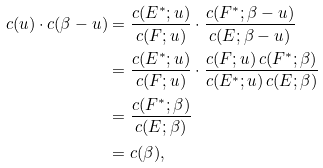Convert formula to latex. <formula><loc_0><loc_0><loc_500><loc_500>c ( u ) \cdot c ( \beta - u ) & = \frac { c ( E ^ { * } ; u ) } { c ( F ; u ) } \cdot \frac { c ( F ^ { * } ; \beta - u ) } { c ( E ; \beta - u ) } \\ & = \frac { c ( E ^ { * } ; u ) } { c ( F ; u ) } \cdot \frac { c ( F ; u ) \, c ( F ^ { * } ; \beta ) } { c ( E ^ { * } ; u ) \, c ( E ; \beta ) } \\ & = \frac { c ( F ^ { * } ; \beta ) } { c ( E ; \beta ) } \\ & = c ( \beta ) ,</formula> 